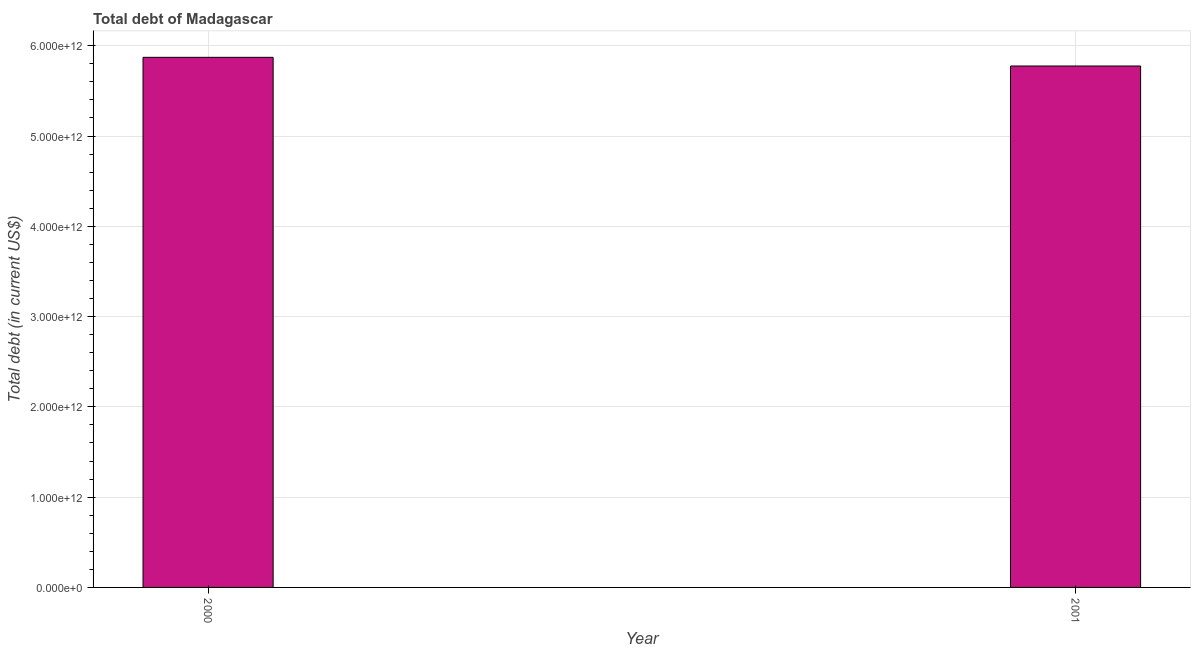Does the graph contain grids?
Provide a succinct answer. Yes. What is the title of the graph?
Keep it short and to the point. Total debt of Madagascar. What is the label or title of the X-axis?
Offer a very short reply. Year. What is the label or title of the Y-axis?
Provide a short and direct response. Total debt (in current US$). What is the total debt in 2000?
Your response must be concise. 5.87e+12. Across all years, what is the maximum total debt?
Provide a succinct answer. 5.87e+12. Across all years, what is the minimum total debt?
Your answer should be very brief. 5.78e+12. In which year was the total debt maximum?
Your answer should be very brief. 2000. In which year was the total debt minimum?
Your response must be concise. 2001. What is the sum of the total debt?
Offer a very short reply. 1.16e+13. What is the difference between the total debt in 2000 and 2001?
Your answer should be very brief. 9.62e+1. What is the average total debt per year?
Your answer should be very brief. 5.82e+12. What is the median total debt?
Your answer should be very brief. 5.82e+12. What is the ratio of the total debt in 2000 to that in 2001?
Offer a very short reply. 1.02. In how many years, is the total debt greater than the average total debt taken over all years?
Your answer should be compact. 1. How many bars are there?
Your response must be concise. 2. Are all the bars in the graph horizontal?
Offer a very short reply. No. What is the difference between two consecutive major ticks on the Y-axis?
Offer a very short reply. 1.00e+12. Are the values on the major ticks of Y-axis written in scientific E-notation?
Keep it short and to the point. Yes. What is the Total debt (in current US$) of 2000?
Provide a succinct answer. 5.87e+12. What is the Total debt (in current US$) of 2001?
Your answer should be very brief. 5.78e+12. What is the difference between the Total debt (in current US$) in 2000 and 2001?
Give a very brief answer. 9.62e+1. What is the ratio of the Total debt (in current US$) in 2000 to that in 2001?
Make the answer very short. 1.02. 